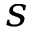<formula> <loc_0><loc_0><loc_500><loc_500>s</formula> 